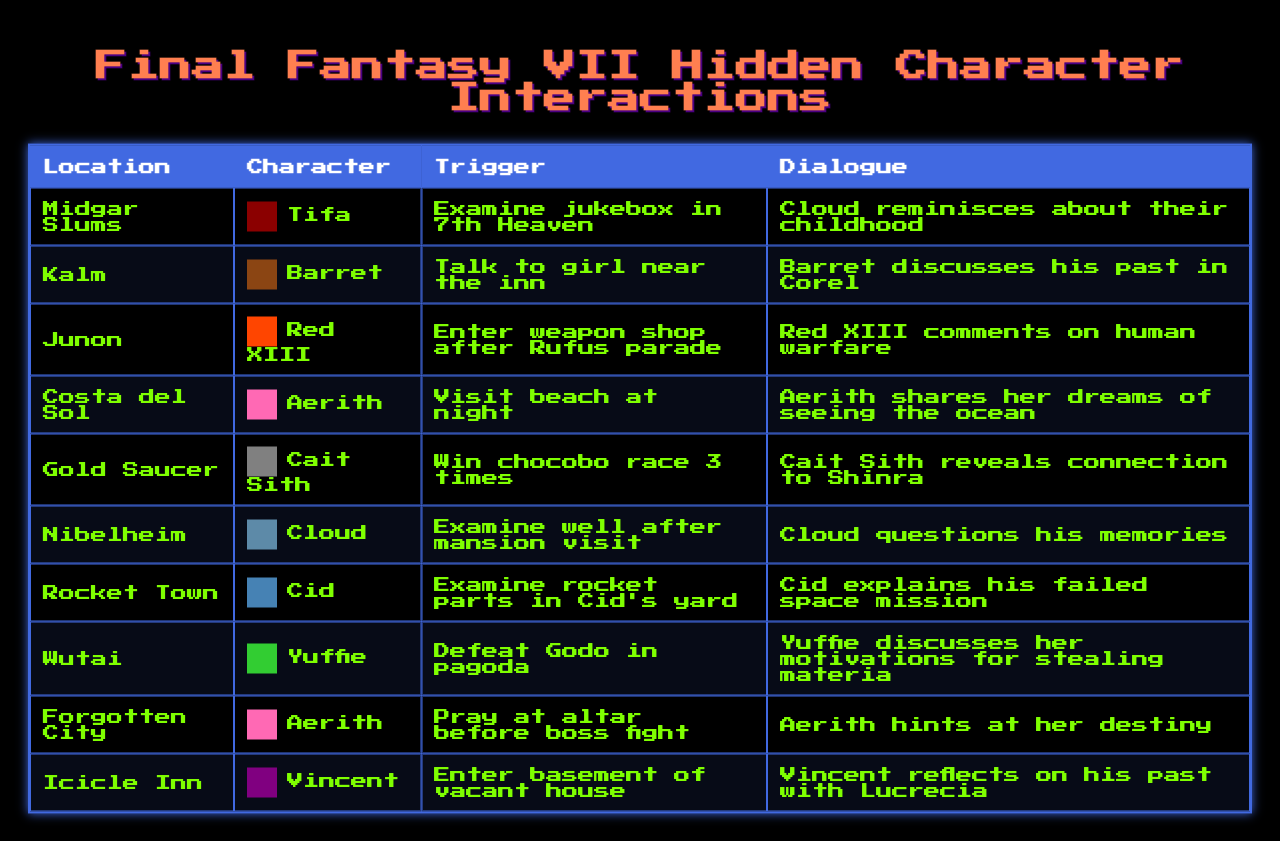What character interacts with Barret in Kalm? The table shows that Barret interacts with a girl near the inn in Kalm.
Answer: The character is Barret What dialogue does Tifa trigger in the Midgar Slums? According to the table, Tifa's dialogue triggered by examining the jukebox in 7th Heaven is about Cloud reminiscing about their childhood.
Answer: Cloud reminisces about their childhood How many interactions are triggered by characters in Costa del Sol? The table indicates there is one interaction triggered by Aerith when visiting the beach at night in Costa del Sol.
Answer: One interaction Which character discusses their past in Corel, and where does this interaction occur? The table reveals that Barret discusses his past in Corel when interacting with a girl near the inn in Kalm.
Answer: Barret in Kalm Is there an interaction involving Aerith in the Forgotten City? The table confirms that there is indeed an interaction involving Aerith, triggered by praying at the altar before the boss fight in Forgotten City.
Answer: Yes What is the trigger for Cloud's dialogue in Nibelheim? The trigger for Cloud's dialogue in Nibelheim is examining the well after the mansion visit, as stated in the table.
Answer: Examine the well after mansion visit Which character has the most interactions listed in the table? By reviewing the table, it can be determined that Aerith has two interactions listed—one in Costa del Sol and one in the Forgotten City.
Answer: Aerith What do you find out about Cid from his interaction in Rocket Town? The table indicates that Cid explains his failed space mission when examining rocket parts in his yard.
Answer: Cid explains his failed space mission Among all interactions, which character's dialogue hints at destiny? According to the table, Aerith's dialogue hints at her destiny when praying at the altar before a boss fight in the Forgotten City.
Answer: Aerith If you win three chocobo races at the Gold Saucer, what does Cait Sith reveal? The table states that winning three chocobo races allows Cait Sith to reveal his connection to Shinra.
Answer: His connection to Shinra 